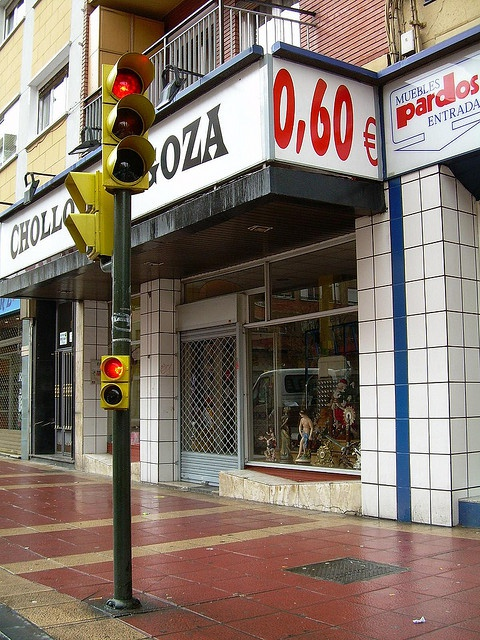Describe the objects in this image and their specific colors. I can see traffic light in tan, black, maroon, and olive tones, traffic light in tan, olive, and gold tones, and traffic light in tan, black, and olive tones in this image. 